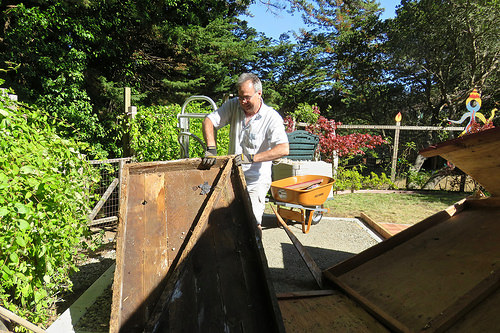<image>
Is the plant behind the fence? No. The plant is not behind the fence. From this viewpoint, the plant appears to be positioned elsewhere in the scene. 